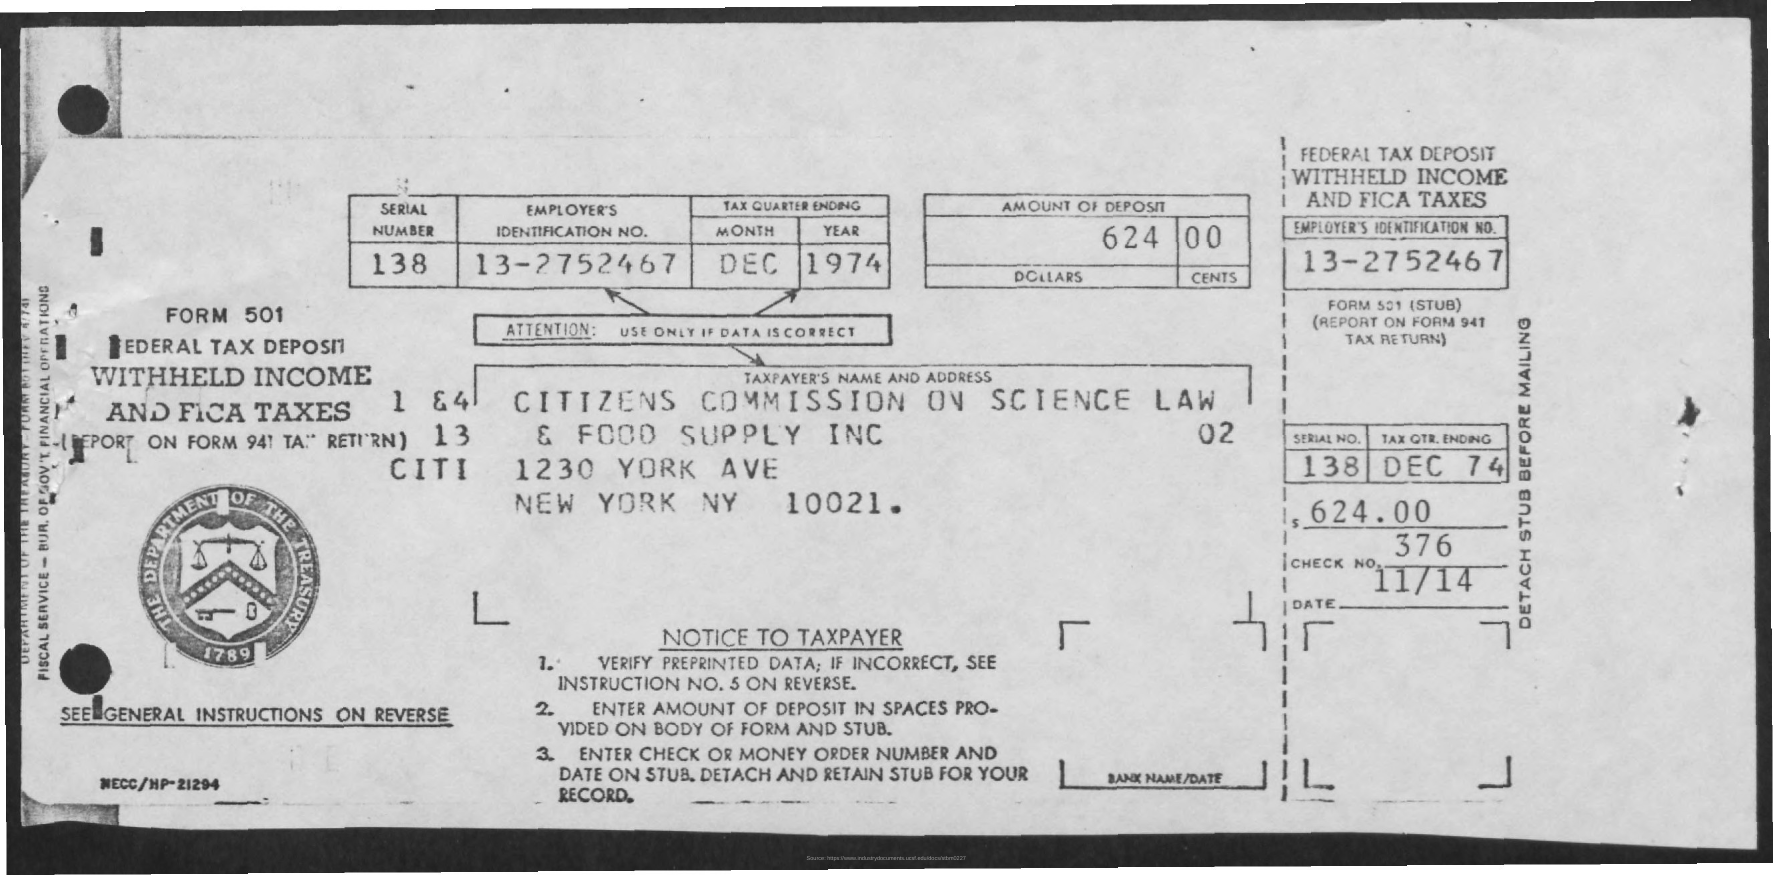What is the Serial Number?
Make the answer very short. 138. What is the Employee Identification Number?
Your answer should be very brief. 13-2752467. What is the Month?
Keep it short and to the point. Dec. What is the Year?
Ensure brevity in your answer.  1974. What is the Amount of Deposit?
Your response must be concise. 624.00. What is the Date?
Give a very brief answer. 11/14. 